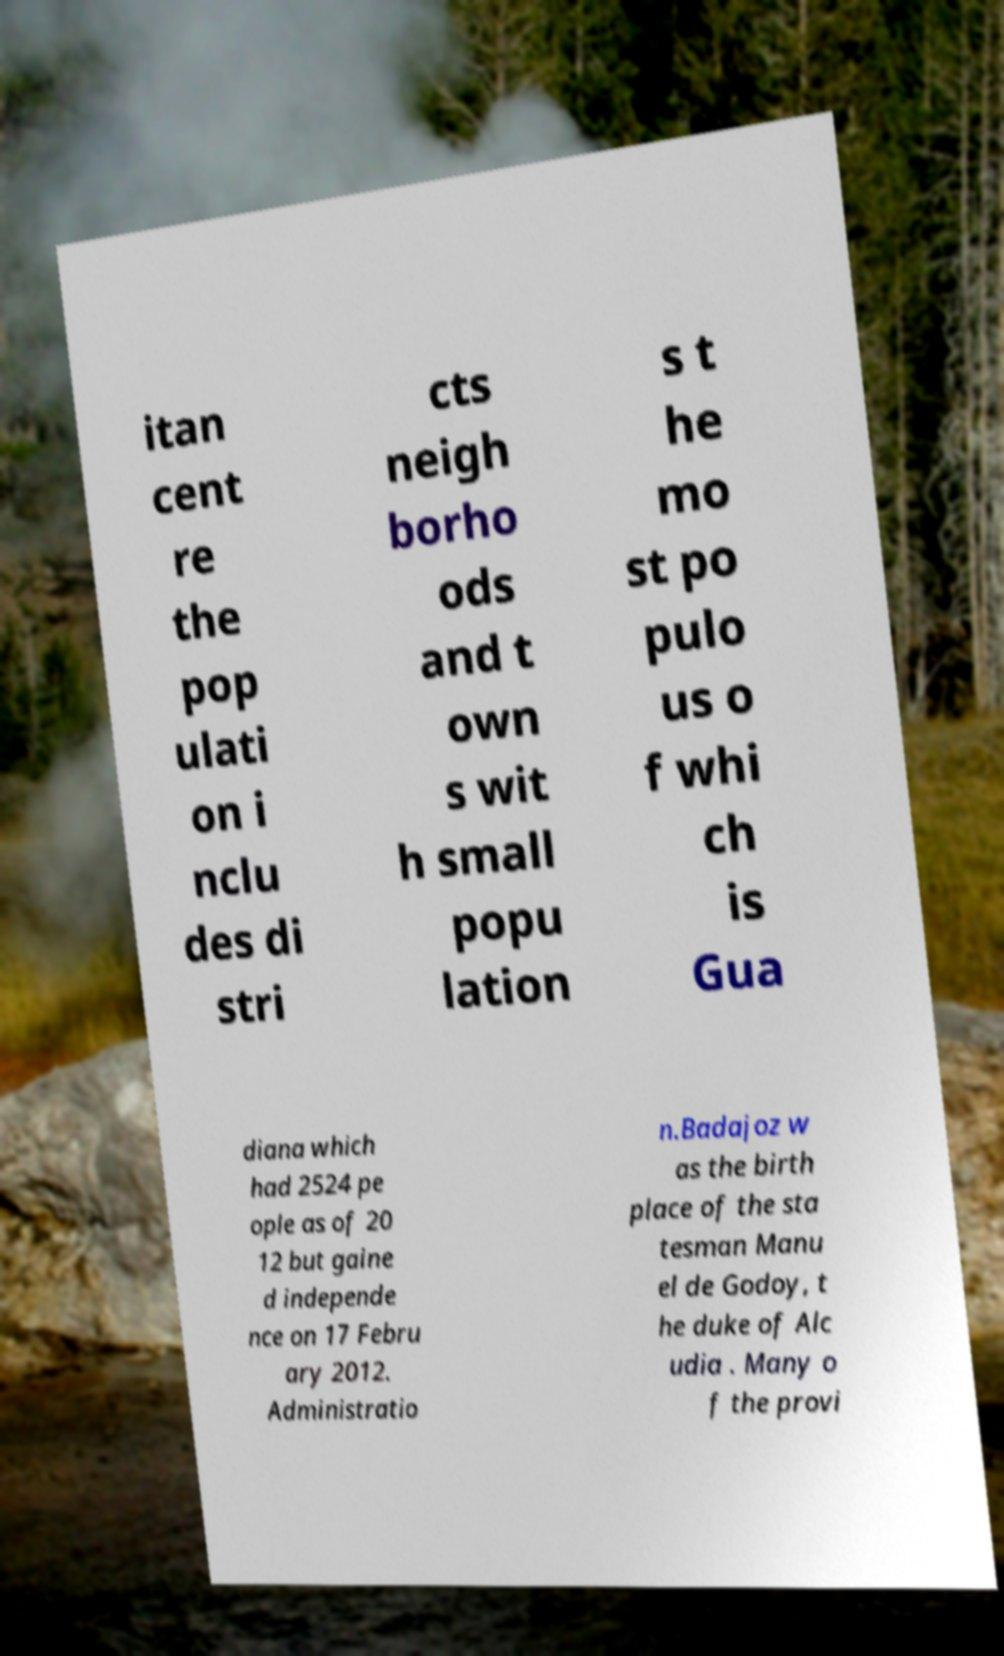What messages or text are displayed in this image? I need them in a readable, typed format. itan cent re the pop ulati on i nclu des di stri cts neigh borho ods and t own s wit h small popu lation s t he mo st po pulo us o f whi ch is Gua diana which had 2524 pe ople as of 20 12 but gaine d independe nce on 17 Febru ary 2012. Administratio n.Badajoz w as the birth place of the sta tesman Manu el de Godoy, t he duke of Alc udia . Many o f the provi 